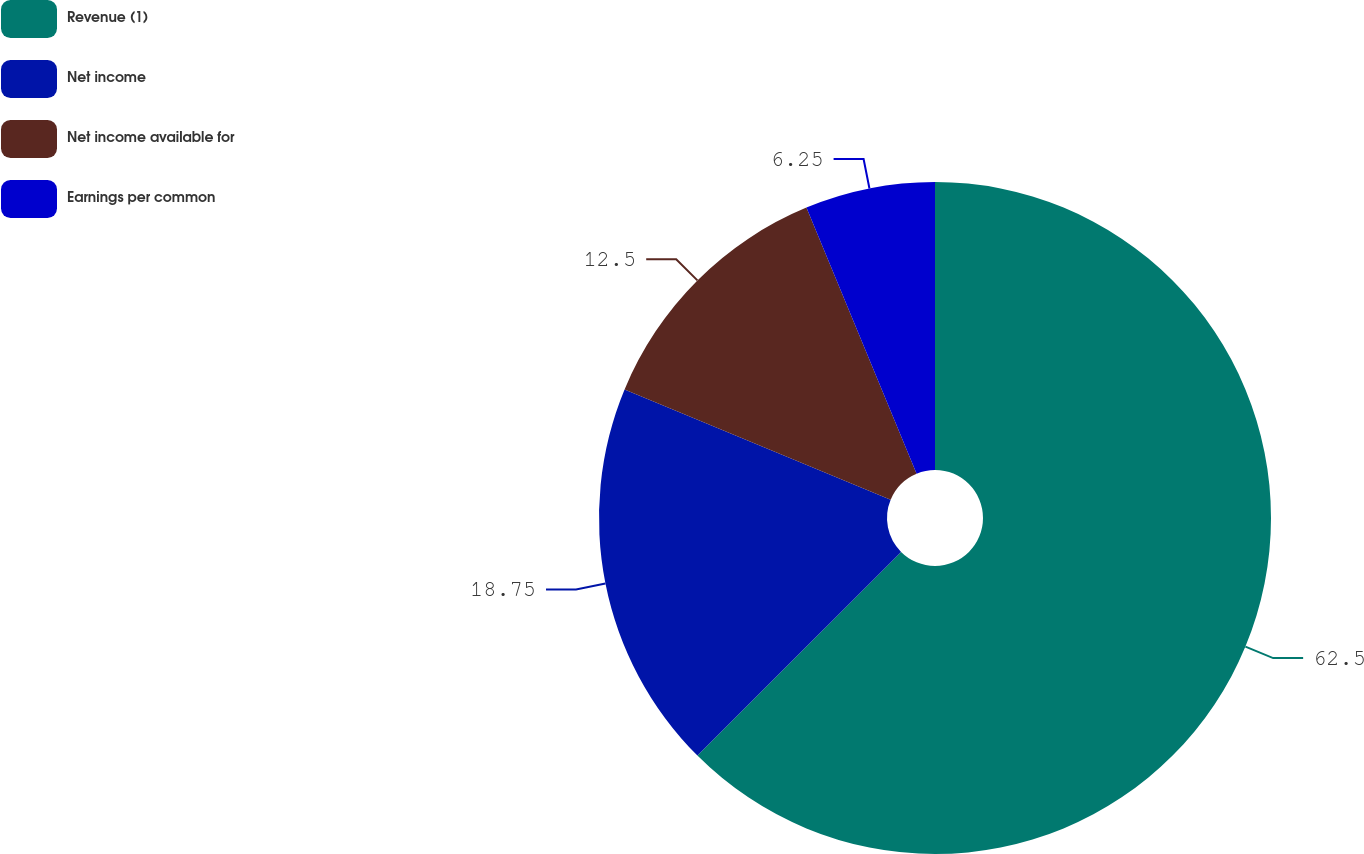Convert chart to OTSL. <chart><loc_0><loc_0><loc_500><loc_500><pie_chart><fcel>Revenue (1)<fcel>Net income<fcel>Net income available for<fcel>Earnings per common<nl><fcel>62.5%<fcel>18.75%<fcel>12.5%<fcel>6.25%<nl></chart> 